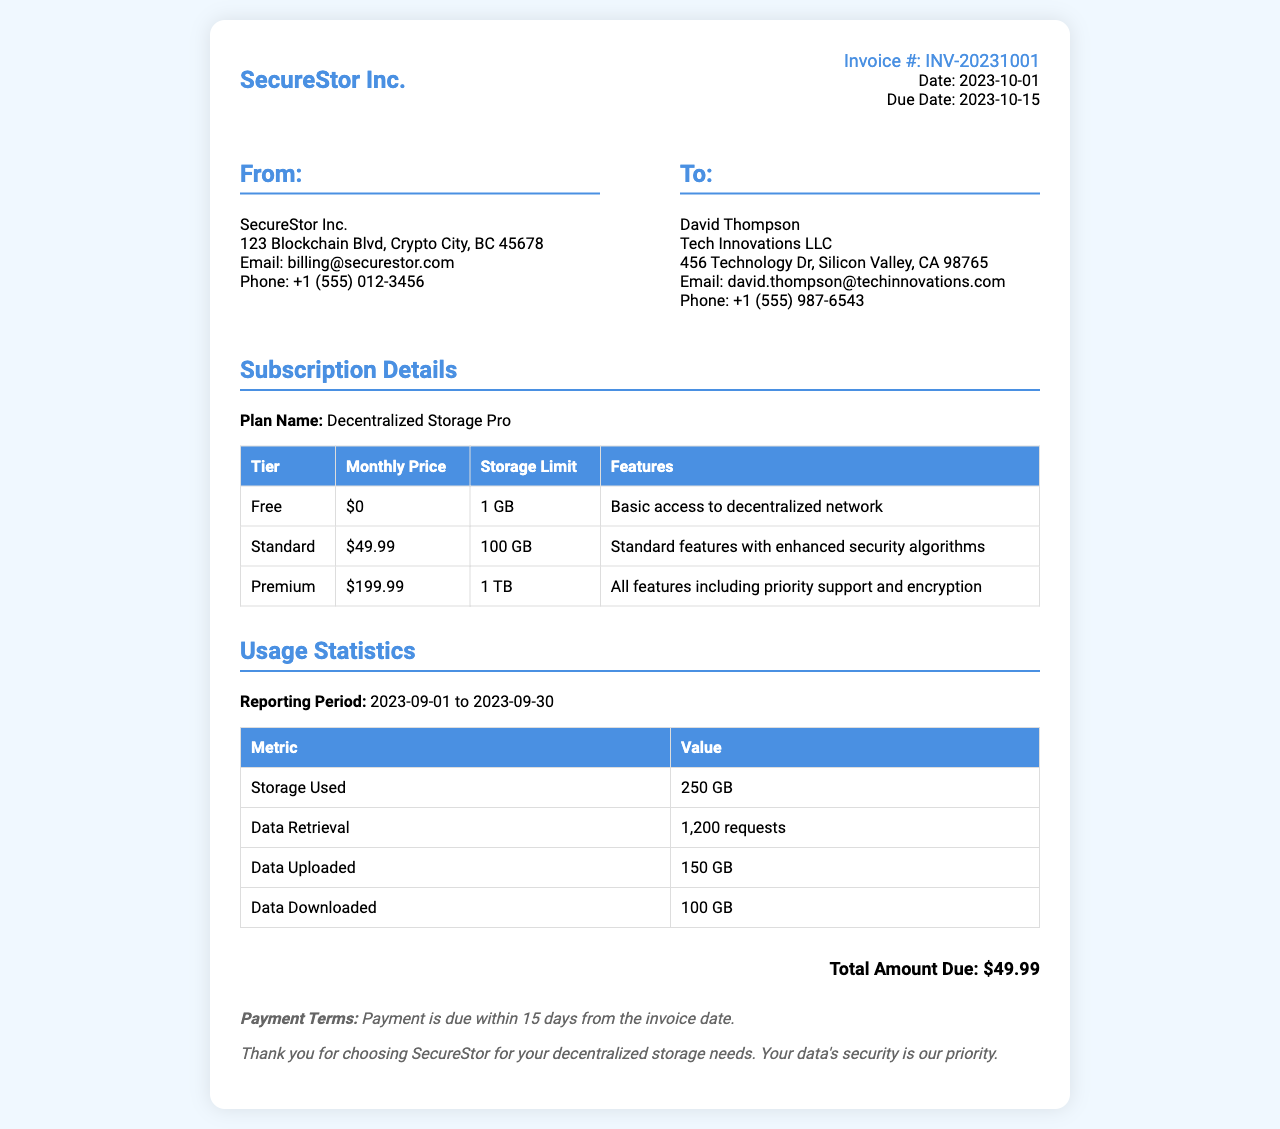what is the invoice number? The invoice number is displayed prominently at the top of the document, indicating the specific invoice being addressed.
Answer: INV-20231001 what is the due date of the invoice? The due date is stated in the invoice details section, showing when the payment is expected.
Answer: 2023-10-15 what is the name of the plan subscribed? The plan name is provided in the subscription details, describing the service being utilized.
Answer: Decentralized Storage Pro how much is the monthly price for the Premium tier? The monthly price for the Premium tier is listed in the tier pricing table, indicating the cost for that level of service.
Answer: $199.99 how much storage has been used in the reporting period? The document specifies the amount of data that has been stored during the reporting period, detailing the usage statistics.
Answer: 250 GB how many requests were made for data retrieval? The number of requests for data retrieval is also included in the usage statistics section of the invoice.
Answer: 1,200 requests what is the total amount due? The total amount due is clearly indicated at the bottom of the invoice, summarizing the cost to be paid.
Answer: $49.99 what are the payment terms stated in the document? The payment terms are outlined in the notes section, providing guidance on when the payment should be made.
Answer: Payment is due within 15 days from the invoice date what features are included in the Standard tier? The features available in the Standard tier are detailed in the tier pricing table, describing what is offered at that level.
Answer: Standard features with enhanced security algorithms 